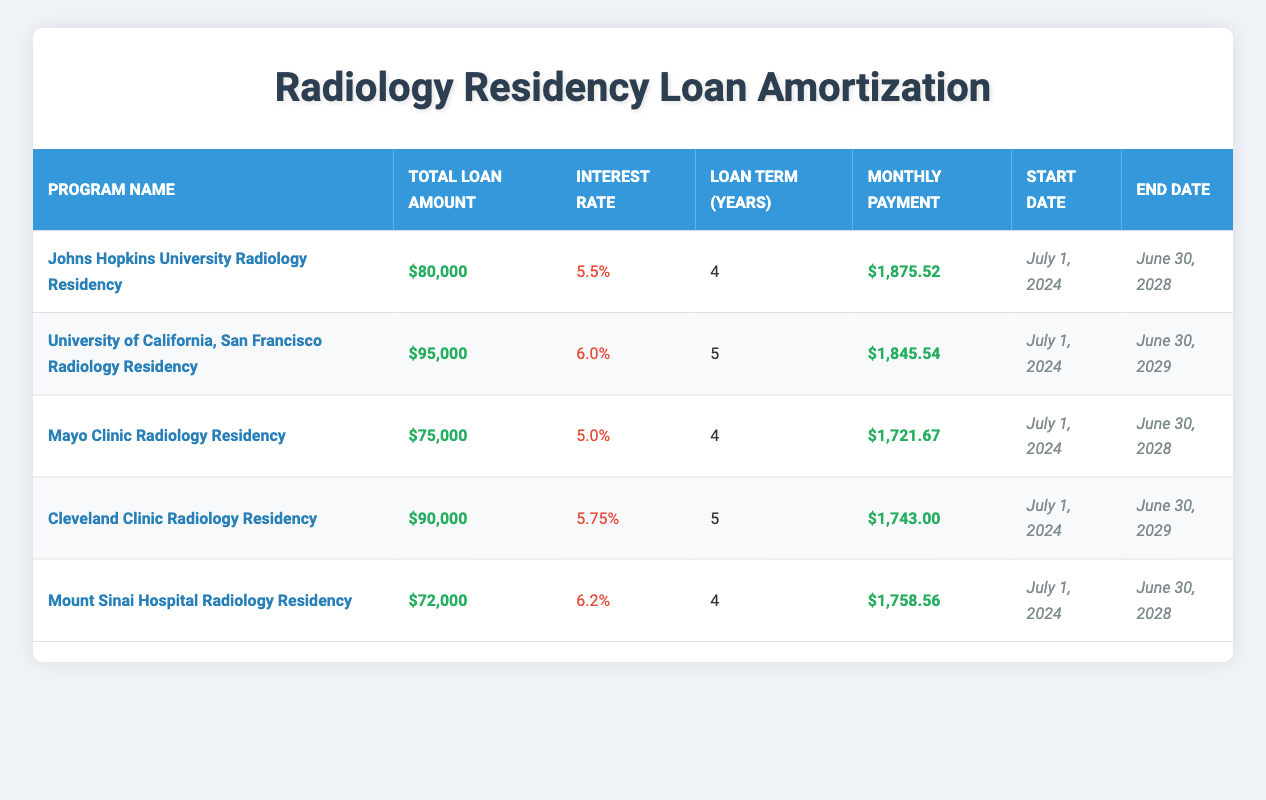What is the interest rate for the Johns Hopkins University Radiology Residency? The interest rate is listed directly in the table for the Johns Hopkins University Radiology Residency program in the "Interest Rate" column. It states 5.5%.
Answer: 5.5% Which program has the highest total loan amount? By comparing the "Total Loan Amount" column for each program, the University of California, San Francisco Radiology Residency has the highest amount at $95,000.
Answer: University of California, San Francisco Radiology Residency What is the monthly payment for the Cleveland Clinic Radiology Residency? The monthly payment is provided in the table under the "Monthly Payment" column for the Cleveland Clinic Radiology Residency, which is stated as $1,743.00.
Answer: $1,743.00 Calculate the average monthly payment across all programs. First, sum the monthly payments: 1875.52 + 1845.54 + 1721.67 + 1743.00 + 1758.56 = 9,114.29. Then, divide by the number of programs, which is 5: 9,114.29 / 5 = 1,822.86.
Answer: $1,822.86 Is the loan term for the Mount Sinai Hospital Radiology Residency shorter than 5 years? The loan term for the Mount Sinai Hospital Radiology Residency is 4 years, which is indeed shorter than 5 years.
Answer: Yes What is the total loan amount of all programs combined? The total loan amounts can be summed: 80000 + 95000 + 75000 + 90000 + 72000 = 412000. So the combined total loan amount is $412,000.
Answer: $412,000 Which program has the lowest interest rate? By examining the "Interest Rate" column, the Mayo Clinic Radiology Residency has the lowest rate of 5.0%.
Answer: Mayo Clinic Radiology Residency Are all programs scheduled to start on the same date? All programs start on July 1, 2024, according to the "Start Date" column in the table, confirming they are all scheduled to start on this date.
Answer: Yes How many programs have a loan term of 4 years? Looking at the "Loan Term (Years)" column, there are three programs (Johns Hopkins, Mayo Clinic, Mount Sinai) with a term of 4 years.
Answer: 3 